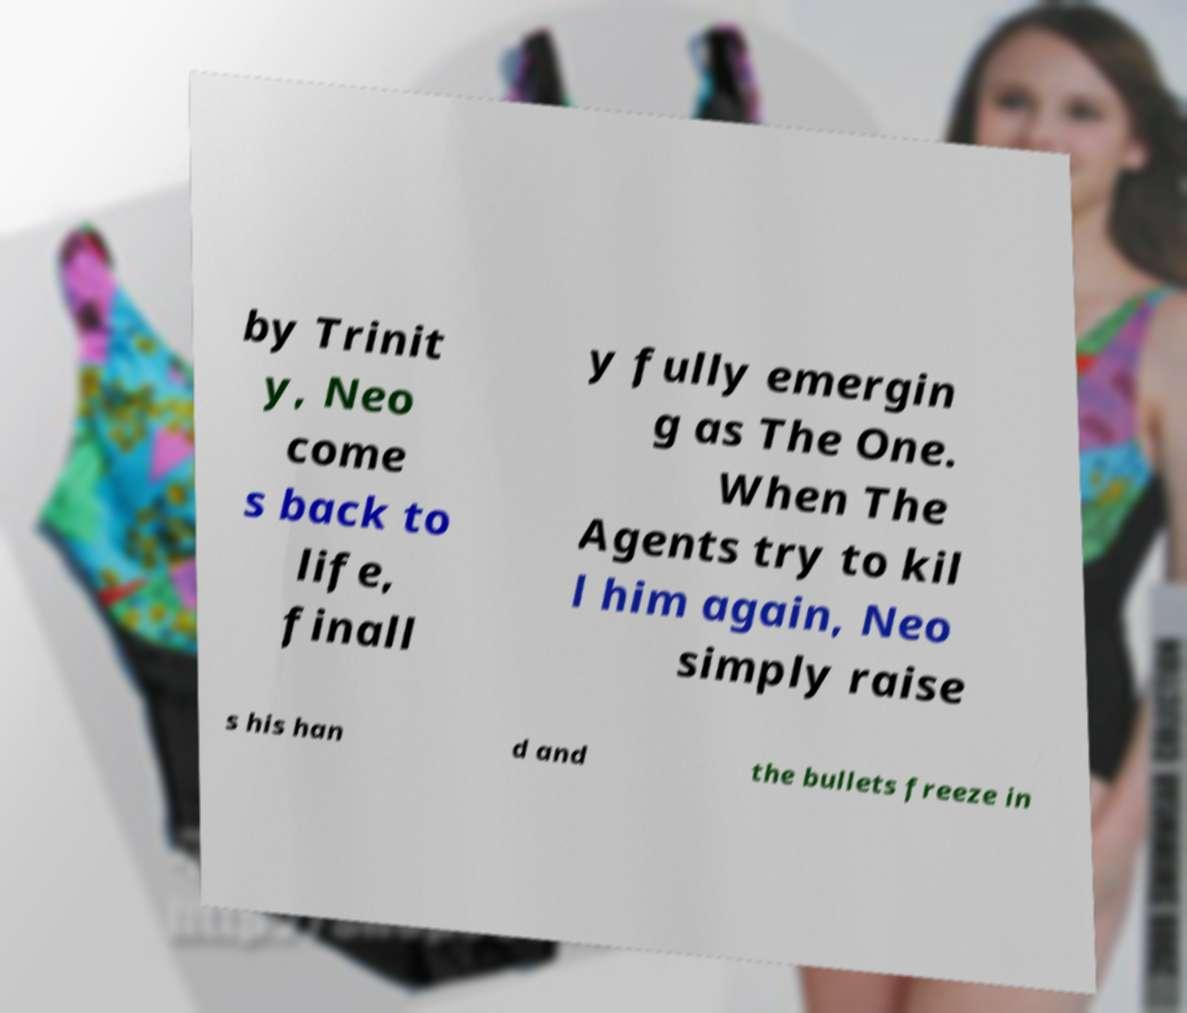Please identify and transcribe the text found in this image. by Trinit y, Neo come s back to life, finall y fully emergin g as The One. When The Agents try to kil l him again, Neo simply raise s his han d and the bullets freeze in 